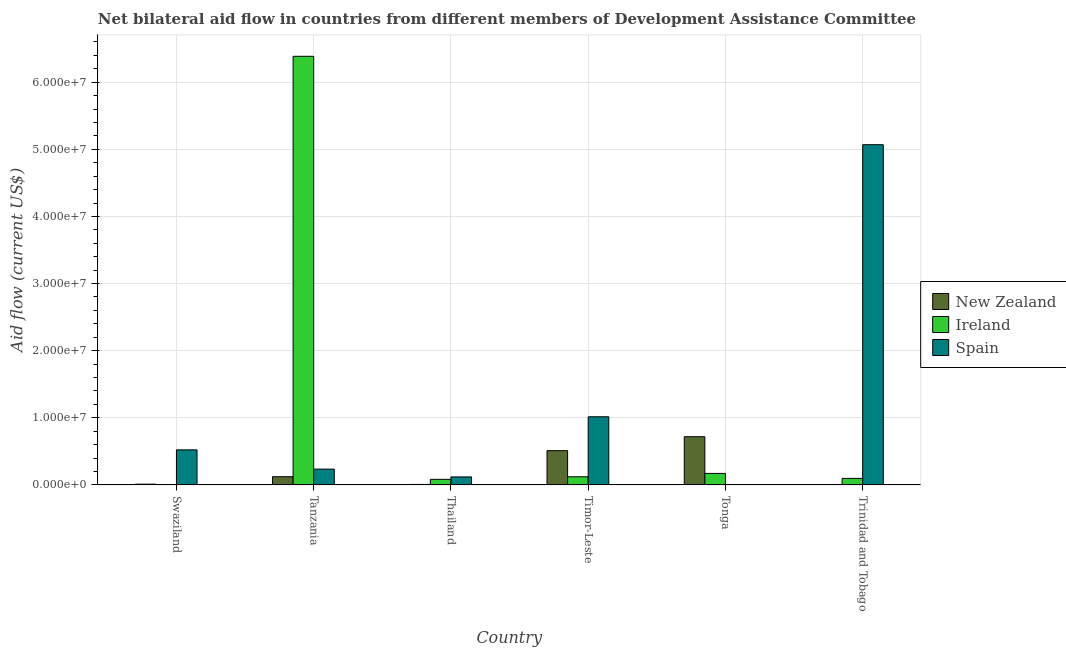Are the number of bars per tick equal to the number of legend labels?
Give a very brief answer. No. How many bars are there on the 3rd tick from the left?
Make the answer very short. 3. What is the label of the 1st group of bars from the left?
Make the answer very short. Swaziland. In how many cases, is the number of bars for a given country not equal to the number of legend labels?
Keep it short and to the point. 1. What is the amount of aid provided by ireland in Trinidad and Tobago?
Your response must be concise. 9.70e+05. Across all countries, what is the maximum amount of aid provided by new zealand?
Your answer should be very brief. 7.18e+06. In which country was the amount of aid provided by spain maximum?
Make the answer very short. Trinidad and Tobago. What is the total amount of aid provided by ireland in the graph?
Provide a succinct answer. 6.86e+07. What is the difference between the amount of aid provided by spain in Timor-Leste and that in Trinidad and Tobago?
Ensure brevity in your answer.  -4.05e+07. What is the difference between the amount of aid provided by spain in Trinidad and Tobago and the amount of aid provided by new zealand in Tanzania?
Your answer should be compact. 4.95e+07. What is the average amount of aid provided by spain per country?
Ensure brevity in your answer.  1.16e+07. What is the difference between the amount of aid provided by spain and amount of aid provided by new zealand in Tanzania?
Keep it short and to the point. 1.13e+06. In how many countries, is the amount of aid provided by ireland greater than 26000000 US$?
Keep it short and to the point. 1. What is the ratio of the amount of aid provided by ireland in Tanzania to that in Timor-Leste?
Your answer should be compact. 52.78. What is the difference between the highest and the second highest amount of aid provided by ireland?
Provide a succinct answer. 6.22e+07. What is the difference between the highest and the lowest amount of aid provided by spain?
Keep it short and to the point. 5.07e+07. In how many countries, is the amount of aid provided by new zealand greater than the average amount of aid provided by new zealand taken over all countries?
Your response must be concise. 2. Is the sum of the amount of aid provided by ireland in Swaziland and Timor-Leste greater than the maximum amount of aid provided by new zealand across all countries?
Make the answer very short. No. Is it the case that in every country, the sum of the amount of aid provided by new zealand and amount of aid provided by ireland is greater than the amount of aid provided by spain?
Ensure brevity in your answer.  No. How many bars are there?
Your answer should be compact. 17. What is the difference between two consecutive major ticks on the Y-axis?
Your answer should be compact. 1.00e+07. Are the values on the major ticks of Y-axis written in scientific E-notation?
Keep it short and to the point. Yes. Does the graph contain grids?
Make the answer very short. Yes. Where does the legend appear in the graph?
Your answer should be very brief. Center right. How many legend labels are there?
Provide a short and direct response. 3. How are the legend labels stacked?
Provide a short and direct response. Vertical. What is the title of the graph?
Your response must be concise. Net bilateral aid flow in countries from different members of Development Assistance Committee. Does "Poland" appear as one of the legend labels in the graph?
Your answer should be very brief. No. What is the label or title of the X-axis?
Offer a terse response. Country. What is the Aid flow (current US$) in New Zealand in Swaziland?
Give a very brief answer. 1.10e+05. What is the Aid flow (current US$) of Spain in Swaziland?
Your answer should be very brief. 5.22e+06. What is the Aid flow (current US$) in New Zealand in Tanzania?
Provide a short and direct response. 1.22e+06. What is the Aid flow (current US$) in Ireland in Tanzania?
Provide a succinct answer. 6.39e+07. What is the Aid flow (current US$) of Spain in Tanzania?
Ensure brevity in your answer.  2.35e+06. What is the Aid flow (current US$) of Ireland in Thailand?
Make the answer very short. 8.30e+05. What is the Aid flow (current US$) in Spain in Thailand?
Ensure brevity in your answer.  1.19e+06. What is the Aid flow (current US$) in New Zealand in Timor-Leste?
Ensure brevity in your answer.  5.10e+06. What is the Aid flow (current US$) in Ireland in Timor-Leste?
Offer a very short reply. 1.21e+06. What is the Aid flow (current US$) of Spain in Timor-Leste?
Provide a succinct answer. 1.02e+07. What is the Aid flow (current US$) in New Zealand in Tonga?
Make the answer very short. 7.18e+06. What is the Aid flow (current US$) of Ireland in Tonga?
Provide a short and direct response. 1.71e+06. What is the Aid flow (current US$) in Spain in Tonga?
Keep it short and to the point. 0. What is the Aid flow (current US$) of Ireland in Trinidad and Tobago?
Your answer should be very brief. 9.70e+05. What is the Aid flow (current US$) in Spain in Trinidad and Tobago?
Offer a terse response. 5.07e+07. Across all countries, what is the maximum Aid flow (current US$) in New Zealand?
Give a very brief answer. 7.18e+06. Across all countries, what is the maximum Aid flow (current US$) of Ireland?
Your response must be concise. 6.39e+07. Across all countries, what is the maximum Aid flow (current US$) in Spain?
Offer a terse response. 5.07e+07. Across all countries, what is the minimum Aid flow (current US$) of New Zealand?
Ensure brevity in your answer.  3.00e+04. Across all countries, what is the minimum Aid flow (current US$) of Ireland?
Provide a succinct answer. 10000. What is the total Aid flow (current US$) in New Zealand in the graph?
Provide a succinct answer. 1.37e+07. What is the total Aid flow (current US$) in Ireland in the graph?
Your response must be concise. 6.86e+07. What is the total Aid flow (current US$) of Spain in the graph?
Your answer should be compact. 6.96e+07. What is the difference between the Aid flow (current US$) in New Zealand in Swaziland and that in Tanzania?
Provide a succinct answer. -1.11e+06. What is the difference between the Aid flow (current US$) in Ireland in Swaziland and that in Tanzania?
Offer a terse response. -6.38e+07. What is the difference between the Aid flow (current US$) of Spain in Swaziland and that in Tanzania?
Your response must be concise. 2.87e+06. What is the difference between the Aid flow (current US$) in New Zealand in Swaziland and that in Thailand?
Your answer should be compact. 4.00e+04. What is the difference between the Aid flow (current US$) of Ireland in Swaziland and that in Thailand?
Keep it short and to the point. -8.20e+05. What is the difference between the Aid flow (current US$) of Spain in Swaziland and that in Thailand?
Offer a terse response. 4.03e+06. What is the difference between the Aid flow (current US$) of New Zealand in Swaziland and that in Timor-Leste?
Offer a terse response. -4.99e+06. What is the difference between the Aid flow (current US$) in Ireland in Swaziland and that in Timor-Leste?
Keep it short and to the point. -1.20e+06. What is the difference between the Aid flow (current US$) of Spain in Swaziland and that in Timor-Leste?
Keep it short and to the point. -4.93e+06. What is the difference between the Aid flow (current US$) of New Zealand in Swaziland and that in Tonga?
Your answer should be compact. -7.07e+06. What is the difference between the Aid flow (current US$) in Ireland in Swaziland and that in Tonga?
Your answer should be compact. -1.70e+06. What is the difference between the Aid flow (current US$) in Ireland in Swaziland and that in Trinidad and Tobago?
Provide a short and direct response. -9.60e+05. What is the difference between the Aid flow (current US$) of Spain in Swaziland and that in Trinidad and Tobago?
Your response must be concise. -4.55e+07. What is the difference between the Aid flow (current US$) of New Zealand in Tanzania and that in Thailand?
Provide a short and direct response. 1.15e+06. What is the difference between the Aid flow (current US$) of Ireland in Tanzania and that in Thailand?
Your response must be concise. 6.30e+07. What is the difference between the Aid flow (current US$) of Spain in Tanzania and that in Thailand?
Make the answer very short. 1.16e+06. What is the difference between the Aid flow (current US$) in New Zealand in Tanzania and that in Timor-Leste?
Your answer should be compact. -3.88e+06. What is the difference between the Aid flow (current US$) of Ireland in Tanzania and that in Timor-Leste?
Offer a very short reply. 6.26e+07. What is the difference between the Aid flow (current US$) of Spain in Tanzania and that in Timor-Leste?
Make the answer very short. -7.80e+06. What is the difference between the Aid flow (current US$) in New Zealand in Tanzania and that in Tonga?
Provide a succinct answer. -5.96e+06. What is the difference between the Aid flow (current US$) of Ireland in Tanzania and that in Tonga?
Ensure brevity in your answer.  6.22e+07. What is the difference between the Aid flow (current US$) in New Zealand in Tanzania and that in Trinidad and Tobago?
Give a very brief answer. 1.19e+06. What is the difference between the Aid flow (current US$) of Ireland in Tanzania and that in Trinidad and Tobago?
Ensure brevity in your answer.  6.29e+07. What is the difference between the Aid flow (current US$) in Spain in Tanzania and that in Trinidad and Tobago?
Give a very brief answer. -4.83e+07. What is the difference between the Aid flow (current US$) of New Zealand in Thailand and that in Timor-Leste?
Make the answer very short. -5.03e+06. What is the difference between the Aid flow (current US$) in Ireland in Thailand and that in Timor-Leste?
Ensure brevity in your answer.  -3.80e+05. What is the difference between the Aid flow (current US$) of Spain in Thailand and that in Timor-Leste?
Give a very brief answer. -8.96e+06. What is the difference between the Aid flow (current US$) in New Zealand in Thailand and that in Tonga?
Provide a short and direct response. -7.11e+06. What is the difference between the Aid flow (current US$) in Ireland in Thailand and that in Tonga?
Ensure brevity in your answer.  -8.80e+05. What is the difference between the Aid flow (current US$) of Spain in Thailand and that in Trinidad and Tobago?
Your response must be concise. -4.95e+07. What is the difference between the Aid flow (current US$) of New Zealand in Timor-Leste and that in Tonga?
Offer a terse response. -2.08e+06. What is the difference between the Aid flow (current US$) in Ireland in Timor-Leste and that in Tonga?
Your answer should be very brief. -5.00e+05. What is the difference between the Aid flow (current US$) of New Zealand in Timor-Leste and that in Trinidad and Tobago?
Your answer should be very brief. 5.07e+06. What is the difference between the Aid flow (current US$) in Spain in Timor-Leste and that in Trinidad and Tobago?
Make the answer very short. -4.05e+07. What is the difference between the Aid flow (current US$) in New Zealand in Tonga and that in Trinidad and Tobago?
Provide a short and direct response. 7.15e+06. What is the difference between the Aid flow (current US$) of Ireland in Tonga and that in Trinidad and Tobago?
Provide a short and direct response. 7.40e+05. What is the difference between the Aid flow (current US$) of New Zealand in Swaziland and the Aid flow (current US$) of Ireland in Tanzania?
Provide a succinct answer. -6.38e+07. What is the difference between the Aid flow (current US$) in New Zealand in Swaziland and the Aid flow (current US$) in Spain in Tanzania?
Give a very brief answer. -2.24e+06. What is the difference between the Aid flow (current US$) in Ireland in Swaziland and the Aid flow (current US$) in Spain in Tanzania?
Your answer should be compact. -2.34e+06. What is the difference between the Aid flow (current US$) in New Zealand in Swaziland and the Aid flow (current US$) in Ireland in Thailand?
Offer a very short reply. -7.20e+05. What is the difference between the Aid flow (current US$) in New Zealand in Swaziland and the Aid flow (current US$) in Spain in Thailand?
Provide a short and direct response. -1.08e+06. What is the difference between the Aid flow (current US$) in Ireland in Swaziland and the Aid flow (current US$) in Spain in Thailand?
Your response must be concise. -1.18e+06. What is the difference between the Aid flow (current US$) of New Zealand in Swaziland and the Aid flow (current US$) of Ireland in Timor-Leste?
Your answer should be very brief. -1.10e+06. What is the difference between the Aid flow (current US$) of New Zealand in Swaziland and the Aid flow (current US$) of Spain in Timor-Leste?
Give a very brief answer. -1.00e+07. What is the difference between the Aid flow (current US$) of Ireland in Swaziland and the Aid flow (current US$) of Spain in Timor-Leste?
Provide a succinct answer. -1.01e+07. What is the difference between the Aid flow (current US$) of New Zealand in Swaziland and the Aid flow (current US$) of Ireland in Tonga?
Your response must be concise. -1.60e+06. What is the difference between the Aid flow (current US$) of New Zealand in Swaziland and the Aid flow (current US$) of Ireland in Trinidad and Tobago?
Keep it short and to the point. -8.60e+05. What is the difference between the Aid flow (current US$) in New Zealand in Swaziland and the Aid flow (current US$) in Spain in Trinidad and Tobago?
Keep it short and to the point. -5.06e+07. What is the difference between the Aid flow (current US$) in Ireland in Swaziland and the Aid flow (current US$) in Spain in Trinidad and Tobago?
Provide a succinct answer. -5.07e+07. What is the difference between the Aid flow (current US$) in New Zealand in Tanzania and the Aid flow (current US$) in Spain in Thailand?
Provide a succinct answer. 3.00e+04. What is the difference between the Aid flow (current US$) of Ireland in Tanzania and the Aid flow (current US$) of Spain in Thailand?
Give a very brief answer. 6.27e+07. What is the difference between the Aid flow (current US$) in New Zealand in Tanzania and the Aid flow (current US$) in Ireland in Timor-Leste?
Make the answer very short. 10000. What is the difference between the Aid flow (current US$) of New Zealand in Tanzania and the Aid flow (current US$) of Spain in Timor-Leste?
Keep it short and to the point. -8.93e+06. What is the difference between the Aid flow (current US$) in Ireland in Tanzania and the Aid flow (current US$) in Spain in Timor-Leste?
Ensure brevity in your answer.  5.37e+07. What is the difference between the Aid flow (current US$) of New Zealand in Tanzania and the Aid flow (current US$) of Ireland in Tonga?
Provide a short and direct response. -4.90e+05. What is the difference between the Aid flow (current US$) in New Zealand in Tanzania and the Aid flow (current US$) in Ireland in Trinidad and Tobago?
Provide a succinct answer. 2.50e+05. What is the difference between the Aid flow (current US$) in New Zealand in Tanzania and the Aid flow (current US$) in Spain in Trinidad and Tobago?
Your answer should be compact. -4.95e+07. What is the difference between the Aid flow (current US$) of Ireland in Tanzania and the Aid flow (current US$) of Spain in Trinidad and Tobago?
Make the answer very short. 1.32e+07. What is the difference between the Aid flow (current US$) in New Zealand in Thailand and the Aid flow (current US$) in Ireland in Timor-Leste?
Keep it short and to the point. -1.14e+06. What is the difference between the Aid flow (current US$) of New Zealand in Thailand and the Aid flow (current US$) of Spain in Timor-Leste?
Your response must be concise. -1.01e+07. What is the difference between the Aid flow (current US$) in Ireland in Thailand and the Aid flow (current US$) in Spain in Timor-Leste?
Make the answer very short. -9.32e+06. What is the difference between the Aid flow (current US$) in New Zealand in Thailand and the Aid flow (current US$) in Ireland in Tonga?
Make the answer very short. -1.64e+06. What is the difference between the Aid flow (current US$) in New Zealand in Thailand and the Aid flow (current US$) in Ireland in Trinidad and Tobago?
Your response must be concise. -9.00e+05. What is the difference between the Aid flow (current US$) in New Zealand in Thailand and the Aid flow (current US$) in Spain in Trinidad and Tobago?
Make the answer very short. -5.06e+07. What is the difference between the Aid flow (current US$) in Ireland in Thailand and the Aid flow (current US$) in Spain in Trinidad and Tobago?
Ensure brevity in your answer.  -4.99e+07. What is the difference between the Aid flow (current US$) in New Zealand in Timor-Leste and the Aid flow (current US$) in Ireland in Tonga?
Provide a succinct answer. 3.39e+06. What is the difference between the Aid flow (current US$) in New Zealand in Timor-Leste and the Aid flow (current US$) in Ireland in Trinidad and Tobago?
Your answer should be very brief. 4.13e+06. What is the difference between the Aid flow (current US$) of New Zealand in Timor-Leste and the Aid flow (current US$) of Spain in Trinidad and Tobago?
Provide a succinct answer. -4.56e+07. What is the difference between the Aid flow (current US$) in Ireland in Timor-Leste and the Aid flow (current US$) in Spain in Trinidad and Tobago?
Make the answer very short. -4.95e+07. What is the difference between the Aid flow (current US$) in New Zealand in Tonga and the Aid flow (current US$) in Ireland in Trinidad and Tobago?
Offer a very short reply. 6.21e+06. What is the difference between the Aid flow (current US$) of New Zealand in Tonga and the Aid flow (current US$) of Spain in Trinidad and Tobago?
Your response must be concise. -4.35e+07. What is the difference between the Aid flow (current US$) in Ireland in Tonga and the Aid flow (current US$) in Spain in Trinidad and Tobago?
Your answer should be compact. -4.90e+07. What is the average Aid flow (current US$) of New Zealand per country?
Your answer should be very brief. 2.28e+06. What is the average Aid flow (current US$) of Ireland per country?
Your answer should be compact. 1.14e+07. What is the average Aid flow (current US$) of Spain per country?
Offer a very short reply. 1.16e+07. What is the difference between the Aid flow (current US$) of New Zealand and Aid flow (current US$) of Spain in Swaziland?
Offer a terse response. -5.11e+06. What is the difference between the Aid flow (current US$) in Ireland and Aid flow (current US$) in Spain in Swaziland?
Provide a succinct answer. -5.21e+06. What is the difference between the Aid flow (current US$) in New Zealand and Aid flow (current US$) in Ireland in Tanzania?
Offer a very short reply. -6.26e+07. What is the difference between the Aid flow (current US$) in New Zealand and Aid flow (current US$) in Spain in Tanzania?
Ensure brevity in your answer.  -1.13e+06. What is the difference between the Aid flow (current US$) of Ireland and Aid flow (current US$) of Spain in Tanzania?
Offer a terse response. 6.15e+07. What is the difference between the Aid flow (current US$) in New Zealand and Aid flow (current US$) in Ireland in Thailand?
Offer a terse response. -7.60e+05. What is the difference between the Aid flow (current US$) of New Zealand and Aid flow (current US$) of Spain in Thailand?
Make the answer very short. -1.12e+06. What is the difference between the Aid flow (current US$) of Ireland and Aid flow (current US$) of Spain in Thailand?
Make the answer very short. -3.60e+05. What is the difference between the Aid flow (current US$) in New Zealand and Aid flow (current US$) in Ireland in Timor-Leste?
Keep it short and to the point. 3.89e+06. What is the difference between the Aid flow (current US$) in New Zealand and Aid flow (current US$) in Spain in Timor-Leste?
Provide a short and direct response. -5.05e+06. What is the difference between the Aid flow (current US$) in Ireland and Aid flow (current US$) in Spain in Timor-Leste?
Ensure brevity in your answer.  -8.94e+06. What is the difference between the Aid flow (current US$) of New Zealand and Aid flow (current US$) of Ireland in Tonga?
Your answer should be compact. 5.47e+06. What is the difference between the Aid flow (current US$) of New Zealand and Aid flow (current US$) of Ireland in Trinidad and Tobago?
Offer a terse response. -9.40e+05. What is the difference between the Aid flow (current US$) of New Zealand and Aid flow (current US$) of Spain in Trinidad and Tobago?
Your response must be concise. -5.07e+07. What is the difference between the Aid flow (current US$) of Ireland and Aid flow (current US$) of Spain in Trinidad and Tobago?
Make the answer very short. -4.97e+07. What is the ratio of the Aid flow (current US$) of New Zealand in Swaziland to that in Tanzania?
Provide a succinct answer. 0.09. What is the ratio of the Aid flow (current US$) of Ireland in Swaziland to that in Tanzania?
Provide a short and direct response. 0. What is the ratio of the Aid flow (current US$) of Spain in Swaziland to that in Tanzania?
Keep it short and to the point. 2.22. What is the ratio of the Aid flow (current US$) in New Zealand in Swaziland to that in Thailand?
Offer a terse response. 1.57. What is the ratio of the Aid flow (current US$) in Ireland in Swaziland to that in Thailand?
Offer a terse response. 0.01. What is the ratio of the Aid flow (current US$) in Spain in Swaziland to that in Thailand?
Keep it short and to the point. 4.39. What is the ratio of the Aid flow (current US$) in New Zealand in Swaziland to that in Timor-Leste?
Your answer should be very brief. 0.02. What is the ratio of the Aid flow (current US$) of Ireland in Swaziland to that in Timor-Leste?
Offer a terse response. 0.01. What is the ratio of the Aid flow (current US$) of Spain in Swaziland to that in Timor-Leste?
Keep it short and to the point. 0.51. What is the ratio of the Aid flow (current US$) of New Zealand in Swaziland to that in Tonga?
Keep it short and to the point. 0.02. What is the ratio of the Aid flow (current US$) in Ireland in Swaziland to that in Tonga?
Give a very brief answer. 0.01. What is the ratio of the Aid flow (current US$) in New Zealand in Swaziland to that in Trinidad and Tobago?
Your response must be concise. 3.67. What is the ratio of the Aid flow (current US$) in Ireland in Swaziland to that in Trinidad and Tobago?
Make the answer very short. 0.01. What is the ratio of the Aid flow (current US$) of Spain in Swaziland to that in Trinidad and Tobago?
Your answer should be compact. 0.1. What is the ratio of the Aid flow (current US$) of New Zealand in Tanzania to that in Thailand?
Offer a terse response. 17.43. What is the ratio of the Aid flow (current US$) of Ireland in Tanzania to that in Thailand?
Give a very brief answer. 76.94. What is the ratio of the Aid flow (current US$) of Spain in Tanzania to that in Thailand?
Offer a very short reply. 1.97. What is the ratio of the Aid flow (current US$) of New Zealand in Tanzania to that in Timor-Leste?
Offer a very short reply. 0.24. What is the ratio of the Aid flow (current US$) in Ireland in Tanzania to that in Timor-Leste?
Your response must be concise. 52.78. What is the ratio of the Aid flow (current US$) in Spain in Tanzania to that in Timor-Leste?
Your response must be concise. 0.23. What is the ratio of the Aid flow (current US$) of New Zealand in Tanzania to that in Tonga?
Your response must be concise. 0.17. What is the ratio of the Aid flow (current US$) of Ireland in Tanzania to that in Tonga?
Offer a very short reply. 37.34. What is the ratio of the Aid flow (current US$) of New Zealand in Tanzania to that in Trinidad and Tobago?
Provide a succinct answer. 40.67. What is the ratio of the Aid flow (current US$) of Ireland in Tanzania to that in Trinidad and Tobago?
Provide a succinct answer. 65.84. What is the ratio of the Aid flow (current US$) in Spain in Tanzania to that in Trinidad and Tobago?
Offer a very short reply. 0.05. What is the ratio of the Aid flow (current US$) of New Zealand in Thailand to that in Timor-Leste?
Give a very brief answer. 0.01. What is the ratio of the Aid flow (current US$) of Ireland in Thailand to that in Timor-Leste?
Make the answer very short. 0.69. What is the ratio of the Aid flow (current US$) in Spain in Thailand to that in Timor-Leste?
Ensure brevity in your answer.  0.12. What is the ratio of the Aid flow (current US$) in New Zealand in Thailand to that in Tonga?
Your answer should be compact. 0.01. What is the ratio of the Aid flow (current US$) in Ireland in Thailand to that in Tonga?
Give a very brief answer. 0.49. What is the ratio of the Aid flow (current US$) of New Zealand in Thailand to that in Trinidad and Tobago?
Provide a succinct answer. 2.33. What is the ratio of the Aid flow (current US$) of Ireland in Thailand to that in Trinidad and Tobago?
Give a very brief answer. 0.86. What is the ratio of the Aid flow (current US$) of Spain in Thailand to that in Trinidad and Tobago?
Make the answer very short. 0.02. What is the ratio of the Aid flow (current US$) of New Zealand in Timor-Leste to that in Tonga?
Make the answer very short. 0.71. What is the ratio of the Aid flow (current US$) in Ireland in Timor-Leste to that in Tonga?
Your answer should be compact. 0.71. What is the ratio of the Aid flow (current US$) of New Zealand in Timor-Leste to that in Trinidad and Tobago?
Give a very brief answer. 170. What is the ratio of the Aid flow (current US$) in Ireland in Timor-Leste to that in Trinidad and Tobago?
Provide a succinct answer. 1.25. What is the ratio of the Aid flow (current US$) of Spain in Timor-Leste to that in Trinidad and Tobago?
Ensure brevity in your answer.  0.2. What is the ratio of the Aid flow (current US$) of New Zealand in Tonga to that in Trinidad and Tobago?
Give a very brief answer. 239.33. What is the ratio of the Aid flow (current US$) of Ireland in Tonga to that in Trinidad and Tobago?
Your answer should be compact. 1.76. What is the difference between the highest and the second highest Aid flow (current US$) of New Zealand?
Your response must be concise. 2.08e+06. What is the difference between the highest and the second highest Aid flow (current US$) in Ireland?
Offer a very short reply. 6.22e+07. What is the difference between the highest and the second highest Aid flow (current US$) in Spain?
Give a very brief answer. 4.05e+07. What is the difference between the highest and the lowest Aid flow (current US$) of New Zealand?
Your response must be concise. 7.15e+06. What is the difference between the highest and the lowest Aid flow (current US$) in Ireland?
Provide a short and direct response. 6.38e+07. What is the difference between the highest and the lowest Aid flow (current US$) in Spain?
Ensure brevity in your answer.  5.07e+07. 